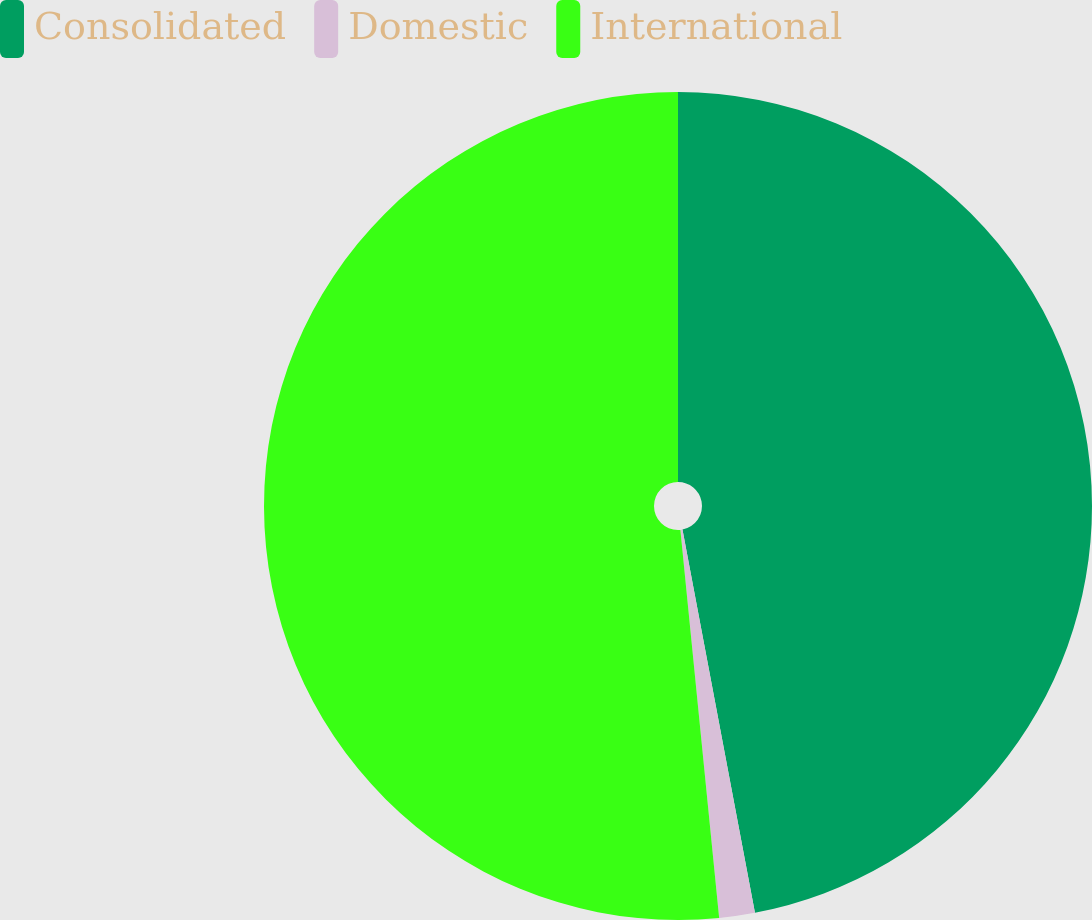Convert chart to OTSL. <chart><loc_0><loc_0><loc_500><loc_500><pie_chart><fcel>Consolidated<fcel>Domestic<fcel>International<nl><fcel>47.02%<fcel>1.39%<fcel>51.58%<nl></chart> 